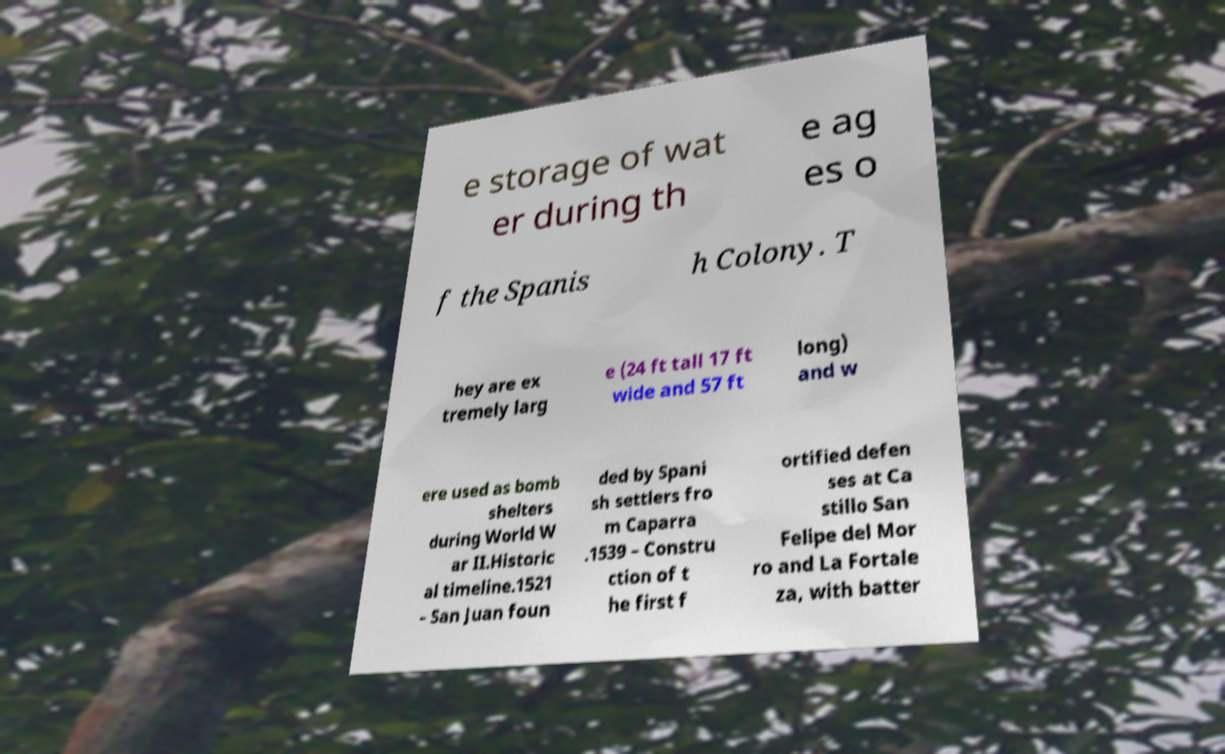Please identify and transcribe the text found in this image. e storage of wat er during th e ag es o f the Spanis h Colony. T hey are ex tremely larg e (24 ft tall 17 ft wide and 57 ft long) and w ere used as bomb shelters during World W ar II.Historic al timeline.1521 – San Juan foun ded by Spani sh settlers fro m Caparra .1539 – Constru ction of t he first f ortified defen ses at Ca stillo San Felipe del Mor ro and La Fortale za, with batter 